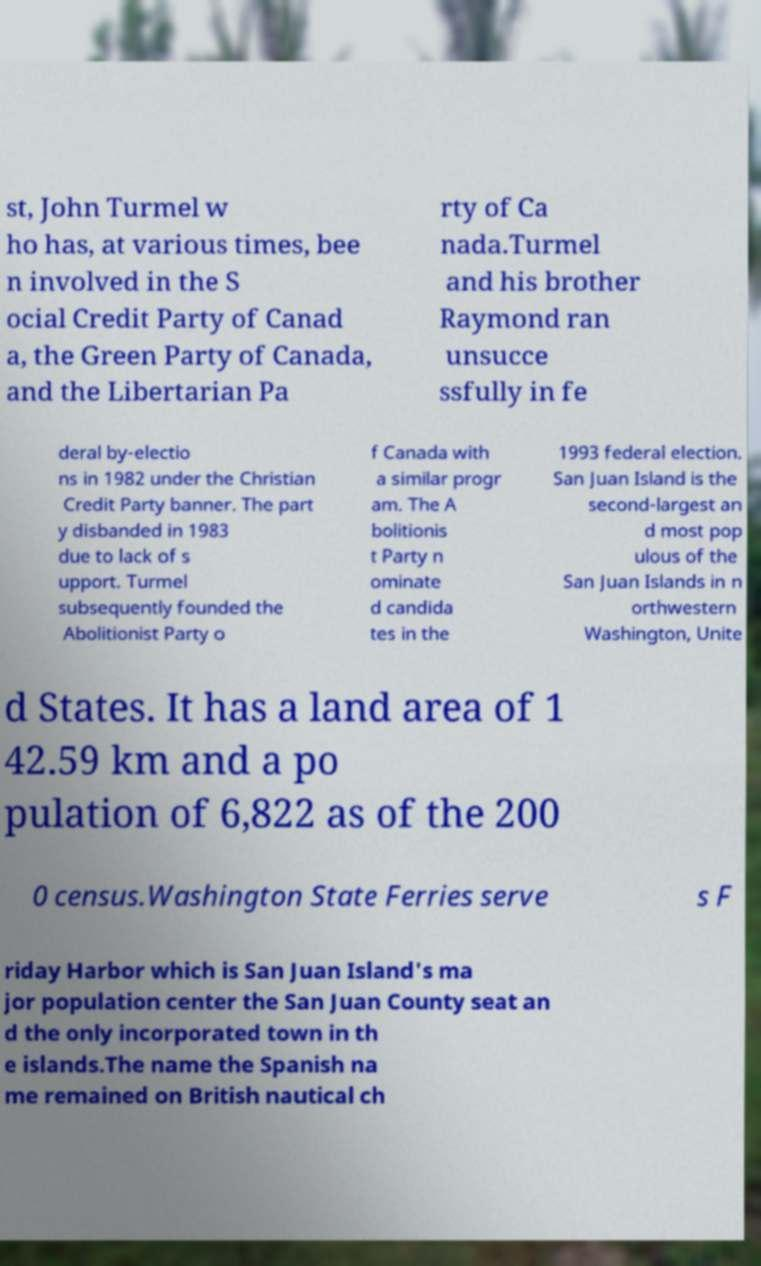Please read and relay the text visible in this image. What does it say? st, John Turmel w ho has, at various times, bee n involved in the S ocial Credit Party of Canad a, the Green Party of Canada, and the Libertarian Pa rty of Ca nada.Turmel and his brother Raymond ran unsucce ssfully in fe deral by-electio ns in 1982 under the Christian Credit Party banner. The part y disbanded in 1983 due to lack of s upport. Turmel subsequently founded the Abolitionist Party o f Canada with a similar progr am. The A bolitionis t Party n ominate d candida tes in the 1993 federal election. San Juan Island is the second-largest an d most pop ulous of the San Juan Islands in n orthwestern Washington, Unite d States. It has a land area of 1 42.59 km and a po pulation of 6,822 as of the 200 0 census.Washington State Ferries serve s F riday Harbor which is San Juan Island's ma jor population center the San Juan County seat an d the only incorporated town in th e islands.The name the Spanish na me remained on British nautical ch 